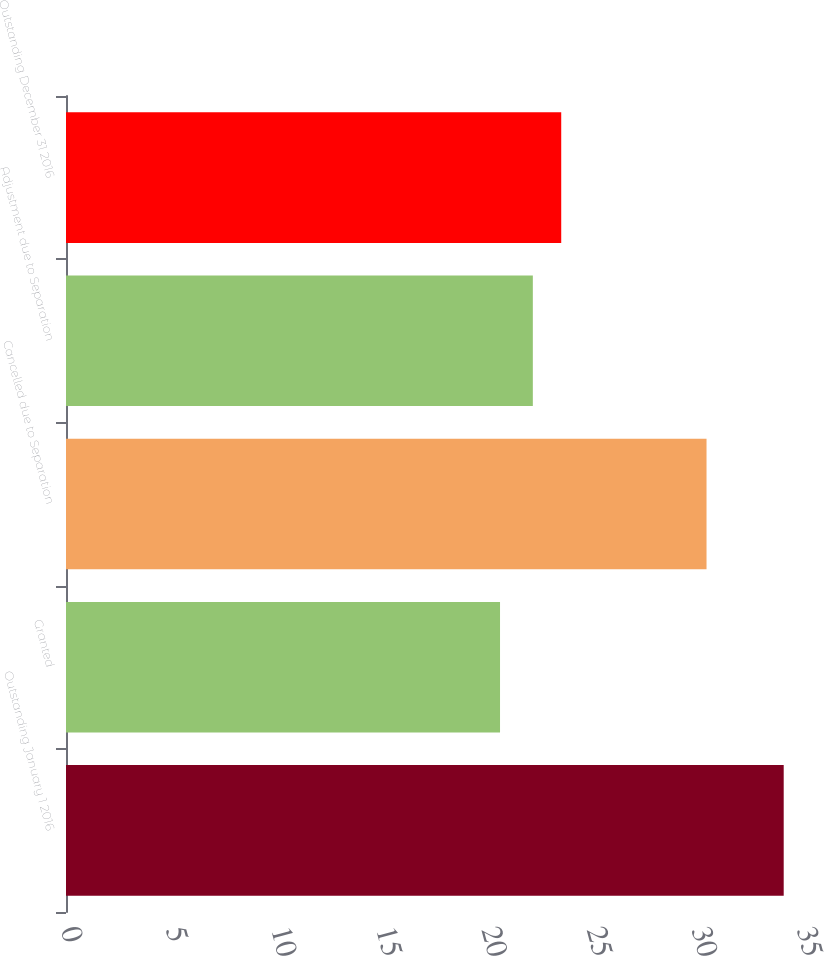Convert chart. <chart><loc_0><loc_0><loc_500><loc_500><bar_chart><fcel>Outstanding January 1 2016<fcel>Granted<fcel>Cancelled due to Separation<fcel>Adjustment due to Separation<fcel>Outstanding December 31 2016<nl><fcel>34.13<fcel>20.64<fcel>30.46<fcel>22.2<fcel>23.55<nl></chart> 